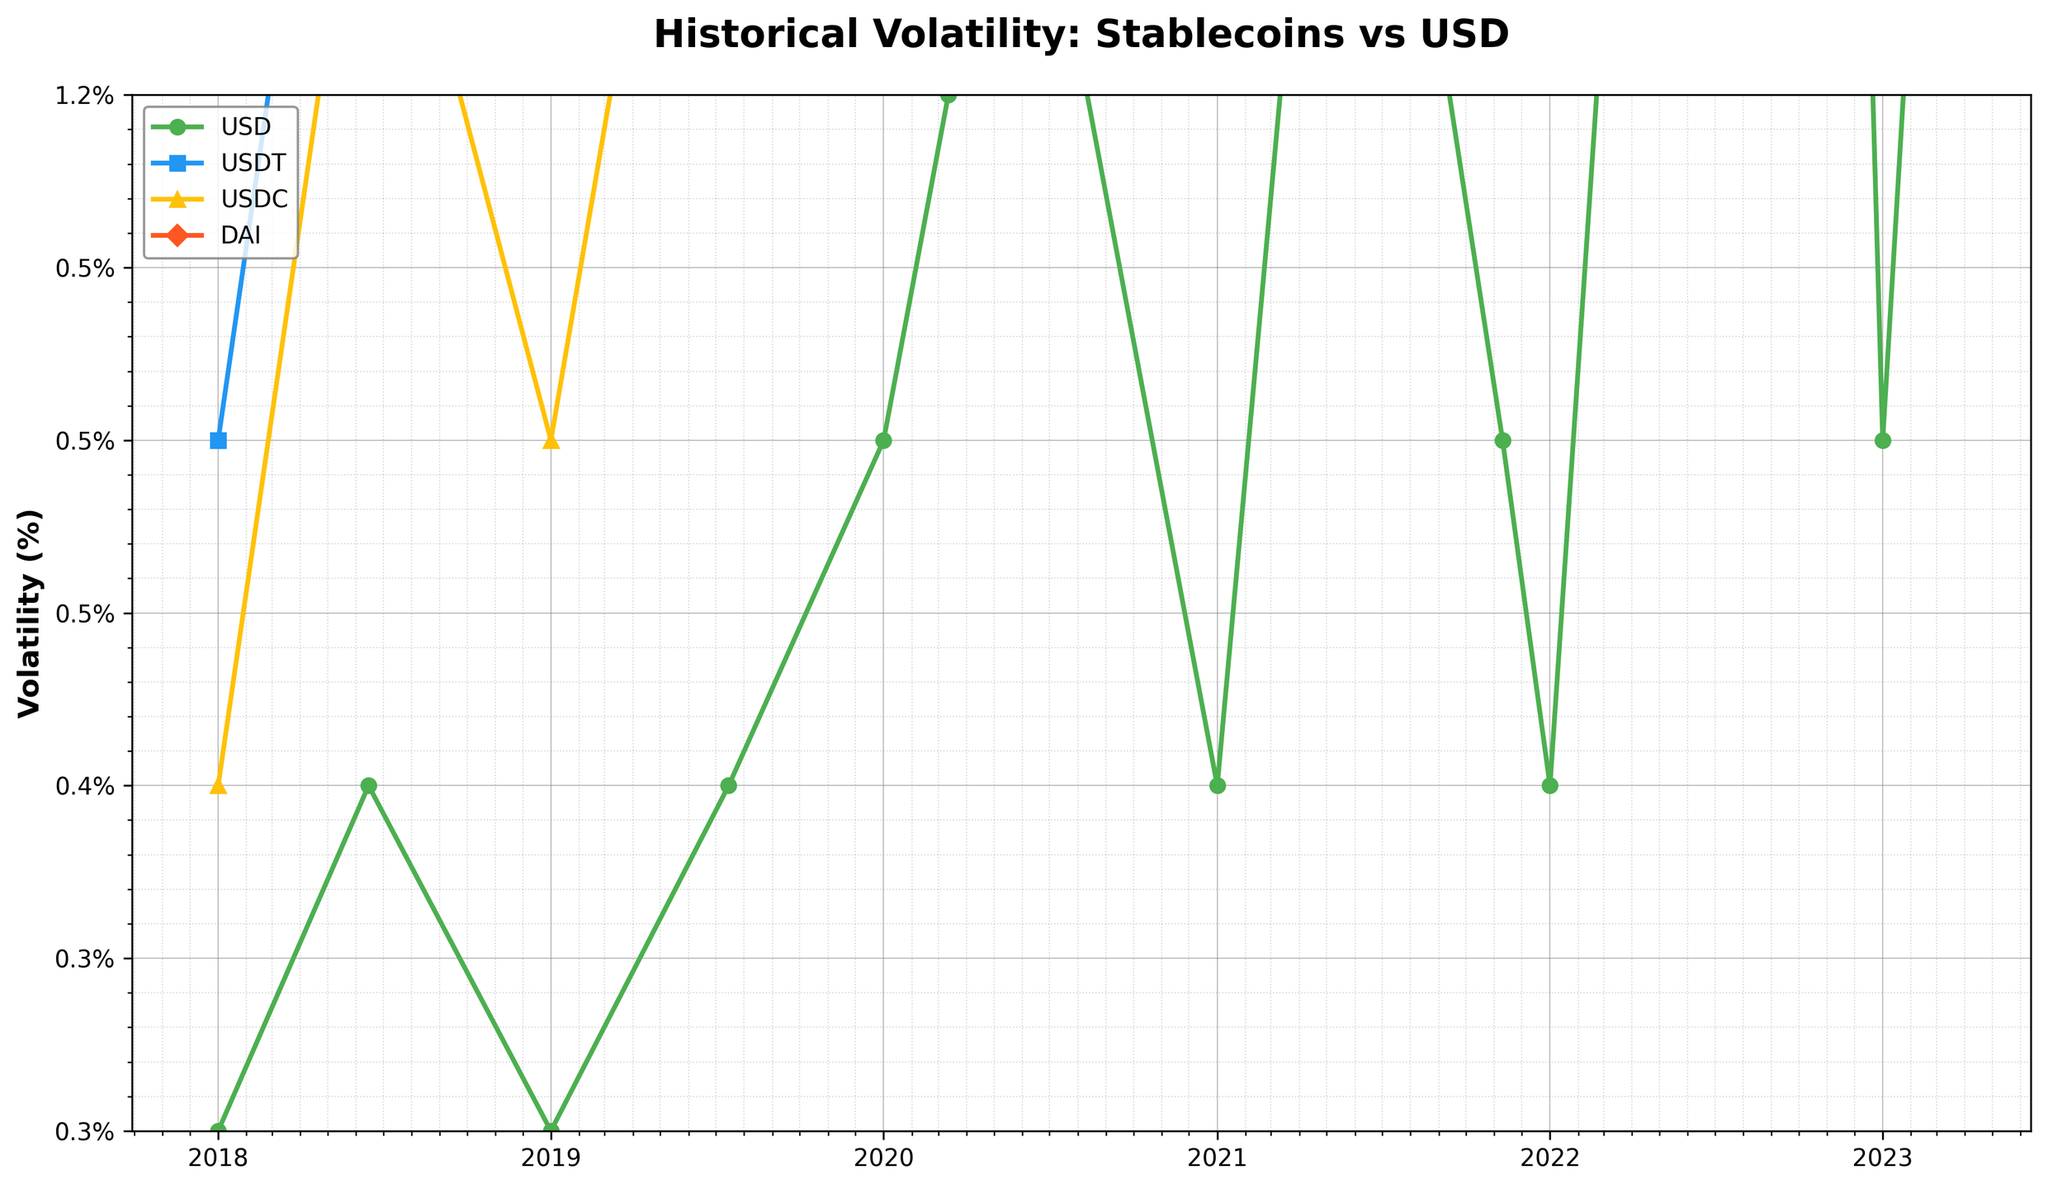Which currency had the highest volatility during the COVID-19 market crash in March 2020? The figure shows different volatility lines for each currency, and during March 2020, the highest volatility observed is for DAI.
Answer: DAI How did the volatility of USDT change from the Tether controversy in June 2018 to the Facebook's Libra announcement in July 2019? By identifying the volatilities of USDT during the mentioned events from the figure, it shows that USDT volatility increased from 0.5% to 0.8%.
Answer: Increased by 0.3% Which event caused the most significant jump in volatility for USDC? Find the event with the largest increase in volatility for USDC by comparing the data before and after each event. The greatest increase is noted during the COVID-19 market crash.
Answer: COVID-19 market crash What is the average volatility of USD in 2023? There are two data points for USD volatility in 2023: 0.5% on January 1 and 0.7% on March 10. The average is (0.5% + 0.7%) / 2.
Answer: 0.6% What was the volatility of DAI during the Terra/LUNA collapse in May 2022? Locate the date corresponding to the Terra/LUNA collapse and observe the volatility of DAI at that point in the chart. The figure shows a DAI volatility of 2.4%.
Answer: 2.4% Compare the volatilities of USD and USDC during the FTX collapse in November 2022. Identify the volatilities for USD and USDC during November 2022 as indicated in the chart. USD volatility was 0.9%, while USDC volatility was 2.2%.
Answer: USDC > USD Did the volatility of stablecoins generally increase, decrease, or stay the same between 2018 and 2023? Compare the general trend of volatility lines for stablecoins (USDT, USDC, DAI) from 2018 to 2023. There is a noticeable upward trend in volatility for these stablecoins.
Answer: Increased Which event had the least impact on the volatility of USD? Examine the chart for notable events and the correspondingly smallest changes in USD volatility. The Tether controversy in June 2018 caused the least noticeable change.
Answer: Tether controversy What is the difference in volatility between USDT and USD during the Silicon Valley Bank failure in March 2023? Identify the volatilities of USDT and USD during the Silicon Valley Bank failure and calculate the difference. USDT volatility was 1.5% and USD volatility was 0.7%. Difference is 1.5% - 0.7%.
Answer: 0.8% 